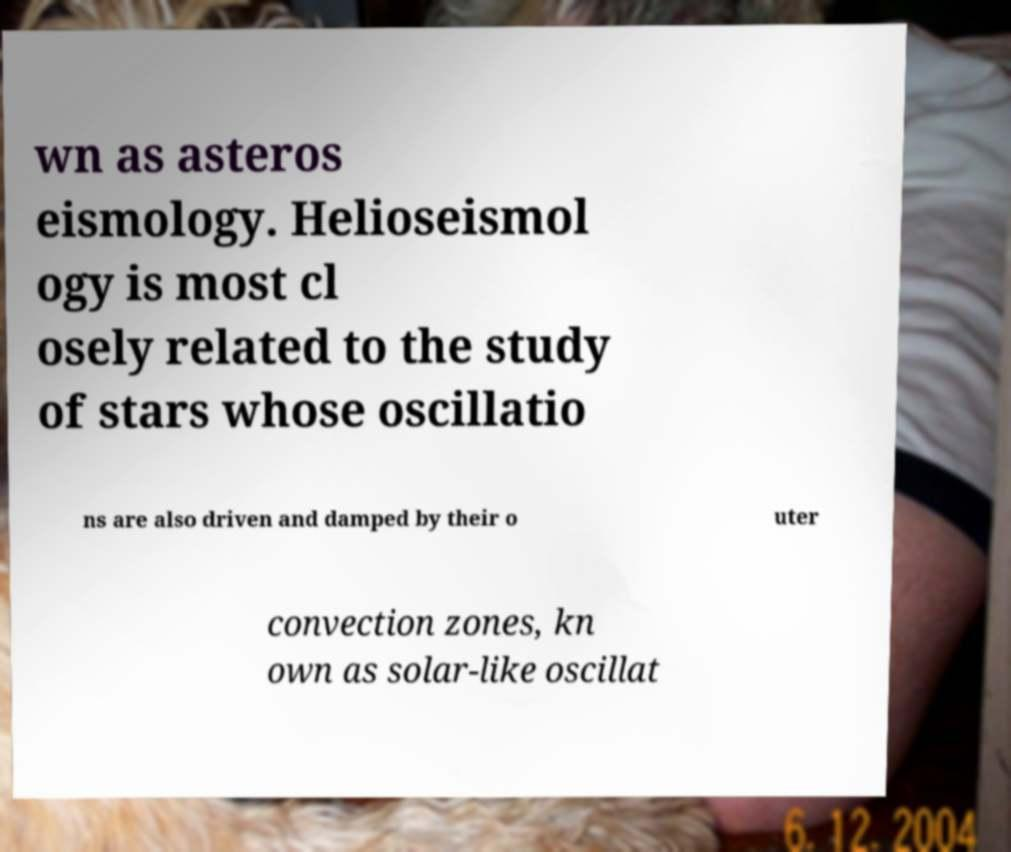I need the written content from this picture converted into text. Can you do that? wn as asteros eismology. Helioseismol ogy is most cl osely related to the study of stars whose oscillatio ns are also driven and damped by their o uter convection zones, kn own as solar-like oscillat 